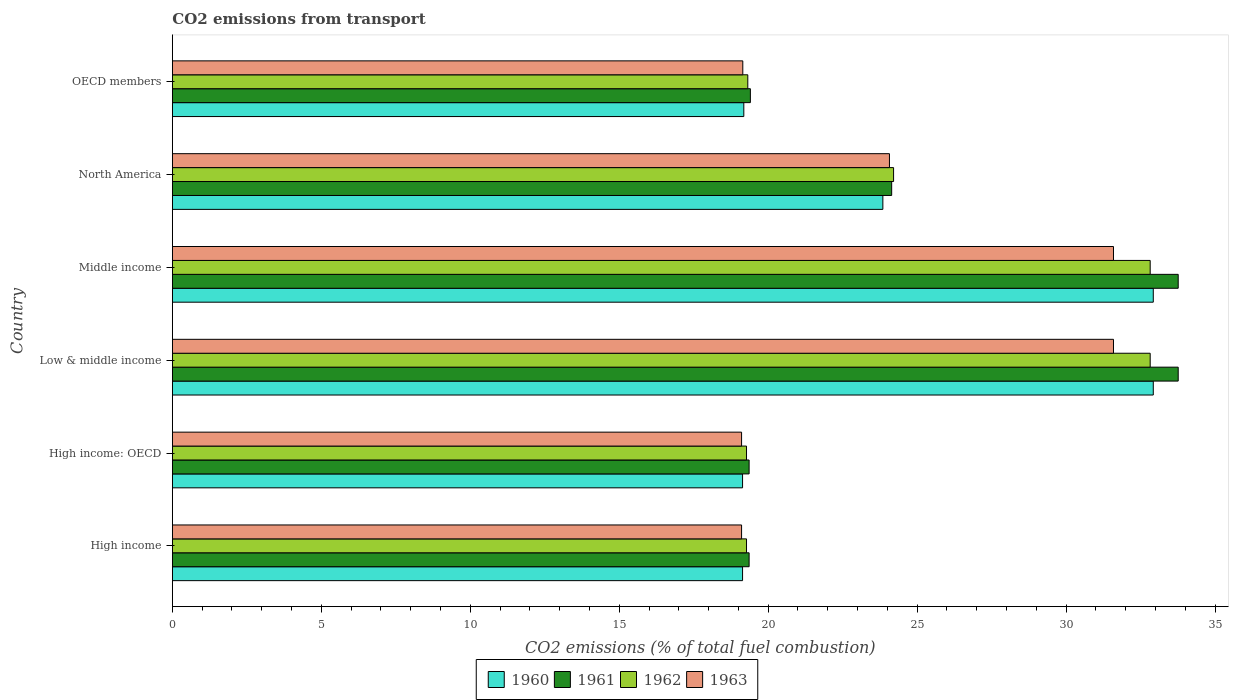Are the number of bars on each tick of the Y-axis equal?
Your answer should be very brief. Yes. In how many cases, is the number of bars for a given country not equal to the number of legend labels?
Make the answer very short. 0. What is the total CO2 emitted in 1960 in OECD members?
Your response must be concise. 19.18. Across all countries, what is the maximum total CO2 emitted in 1962?
Offer a terse response. 32.82. Across all countries, what is the minimum total CO2 emitted in 1962?
Your response must be concise. 19.27. In which country was the total CO2 emitted in 1961 maximum?
Ensure brevity in your answer.  Low & middle income. What is the total total CO2 emitted in 1962 in the graph?
Your answer should be very brief. 147.72. What is the difference between the total CO2 emitted in 1963 in High income and that in Middle income?
Offer a very short reply. -12.48. What is the difference between the total CO2 emitted in 1963 in OECD members and the total CO2 emitted in 1960 in High income?
Offer a terse response. 0.01. What is the average total CO2 emitted in 1960 per country?
Your response must be concise. 24.53. What is the difference between the total CO2 emitted in 1960 and total CO2 emitted in 1963 in High income: OECD?
Your answer should be very brief. 0.03. In how many countries, is the total CO2 emitted in 1963 greater than 7 ?
Your answer should be very brief. 6. What is the ratio of the total CO2 emitted in 1960 in Middle income to that in North America?
Offer a very short reply. 1.38. Is the total CO2 emitted in 1960 in High income: OECD less than that in Middle income?
Provide a short and direct response. Yes. Is the difference between the total CO2 emitted in 1960 in North America and OECD members greater than the difference between the total CO2 emitted in 1963 in North America and OECD members?
Keep it short and to the point. No. What is the difference between the highest and the lowest total CO2 emitted in 1960?
Your response must be concise. 13.79. In how many countries, is the total CO2 emitted in 1963 greater than the average total CO2 emitted in 1963 taken over all countries?
Offer a very short reply. 2. Is the sum of the total CO2 emitted in 1960 in High income: OECD and North America greater than the maximum total CO2 emitted in 1961 across all countries?
Provide a succinct answer. Yes. Is it the case that in every country, the sum of the total CO2 emitted in 1963 and total CO2 emitted in 1960 is greater than the sum of total CO2 emitted in 1961 and total CO2 emitted in 1962?
Your answer should be compact. No. What does the 3rd bar from the bottom in Middle income represents?
Provide a short and direct response. 1962. How many countries are there in the graph?
Provide a succinct answer. 6. What is the difference between two consecutive major ticks on the X-axis?
Your answer should be very brief. 5. Are the values on the major ticks of X-axis written in scientific E-notation?
Offer a very short reply. No. How many legend labels are there?
Your answer should be very brief. 4. How are the legend labels stacked?
Ensure brevity in your answer.  Horizontal. What is the title of the graph?
Offer a terse response. CO2 emissions from transport. Does "1981" appear as one of the legend labels in the graph?
Give a very brief answer. No. What is the label or title of the X-axis?
Make the answer very short. CO2 emissions (% of total fuel combustion). What is the CO2 emissions (% of total fuel combustion) of 1960 in High income?
Ensure brevity in your answer.  19.14. What is the CO2 emissions (% of total fuel combustion) of 1961 in High income?
Your response must be concise. 19.36. What is the CO2 emissions (% of total fuel combustion) of 1962 in High income?
Your answer should be very brief. 19.27. What is the CO2 emissions (% of total fuel combustion) of 1963 in High income?
Your answer should be very brief. 19.11. What is the CO2 emissions (% of total fuel combustion) in 1960 in High income: OECD?
Keep it short and to the point. 19.14. What is the CO2 emissions (% of total fuel combustion) in 1961 in High income: OECD?
Your response must be concise. 19.36. What is the CO2 emissions (% of total fuel combustion) in 1962 in High income: OECD?
Your answer should be very brief. 19.27. What is the CO2 emissions (% of total fuel combustion) of 1963 in High income: OECD?
Ensure brevity in your answer.  19.11. What is the CO2 emissions (% of total fuel combustion) in 1960 in Low & middle income?
Your answer should be very brief. 32.93. What is the CO2 emissions (% of total fuel combustion) of 1961 in Low & middle income?
Keep it short and to the point. 33.76. What is the CO2 emissions (% of total fuel combustion) of 1962 in Low & middle income?
Your answer should be compact. 32.82. What is the CO2 emissions (% of total fuel combustion) of 1963 in Low & middle income?
Your answer should be very brief. 31.59. What is the CO2 emissions (% of total fuel combustion) of 1960 in Middle income?
Offer a very short reply. 32.93. What is the CO2 emissions (% of total fuel combustion) of 1961 in Middle income?
Ensure brevity in your answer.  33.76. What is the CO2 emissions (% of total fuel combustion) in 1962 in Middle income?
Provide a short and direct response. 32.82. What is the CO2 emissions (% of total fuel combustion) of 1963 in Middle income?
Offer a terse response. 31.59. What is the CO2 emissions (% of total fuel combustion) of 1960 in North America?
Offer a terse response. 23.85. What is the CO2 emissions (% of total fuel combustion) of 1961 in North America?
Your answer should be very brief. 24.15. What is the CO2 emissions (% of total fuel combustion) of 1962 in North America?
Your answer should be compact. 24.21. What is the CO2 emissions (% of total fuel combustion) in 1963 in North America?
Provide a short and direct response. 24.07. What is the CO2 emissions (% of total fuel combustion) of 1960 in OECD members?
Provide a short and direct response. 19.18. What is the CO2 emissions (% of total fuel combustion) in 1961 in OECD members?
Give a very brief answer. 19.4. What is the CO2 emissions (% of total fuel combustion) in 1962 in OECD members?
Your response must be concise. 19.32. What is the CO2 emissions (% of total fuel combustion) of 1963 in OECD members?
Offer a terse response. 19.15. Across all countries, what is the maximum CO2 emissions (% of total fuel combustion) in 1960?
Provide a short and direct response. 32.93. Across all countries, what is the maximum CO2 emissions (% of total fuel combustion) in 1961?
Provide a succinct answer. 33.76. Across all countries, what is the maximum CO2 emissions (% of total fuel combustion) of 1962?
Your answer should be compact. 32.82. Across all countries, what is the maximum CO2 emissions (% of total fuel combustion) of 1963?
Your answer should be compact. 31.59. Across all countries, what is the minimum CO2 emissions (% of total fuel combustion) in 1960?
Keep it short and to the point. 19.14. Across all countries, what is the minimum CO2 emissions (% of total fuel combustion) in 1961?
Your answer should be very brief. 19.36. Across all countries, what is the minimum CO2 emissions (% of total fuel combustion) in 1962?
Your response must be concise. 19.27. Across all countries, what is the minimum CO2 emissions (% of total fuel combustion) of 1963?
Keep it short and to the point. 19.11. What is the total CO2 emissions (% of total fuel combustion) in 1960 in the graph?
Your response must be concise. 147.17. What is the total CO2 emissions (% of total fuel combustion) of 1961 in the graph?
Give a very brief answer. 149.8. What is the total CO2 emissions (% of total fuel combustion) of 1962 in the graph?
Give a very brief answer. 147.72. What is the total CO2 emissions (% of total fuel combustion) of 1963 in the graph?
Give a very brief answer. 144.62. What is the difference between the CO2 emissions (% of total fuel combustion) in 1960 in High income and that in High income: OECD?
Your answer should be very brief. 0. What is the difference between the CO2 emissions (% of total fuel combustion) in 1961 in High income and that in High income: OECD?
Offer a very short reply. 0. What is the difference between the CO2 emissions (% of total fuel combustion) of 1962 in High income and that in High income: OECD?
Your answer should be very brief. 0. What is the difference between the CO2 emissions (% of total fuel combustion) in 1963 in High income and that in High income: OECD?
Make the answer very short. 0. What is the difference between the CO2 emissions (% of total fuel combustion) of 1960 in High income and that in Low & middle income?
Offer a very short reply. -13.79. What is the difference between the CO2 emissions (% of total fuel combustion) of 1961 in High income and that in Low & middle income?
Provide a succinct answer. -14.4. What is the difference between the CO2 emissions (% of total fuel combustion) in 1962 in High income and that in Low & middle income?
Keep it short and to the point. -13.55. What is the difference between the CO2 emissions (% of total fuel combustion) of 1963 in High income and that in Low & middle income?
Offer a very short reply. -12.48. What is the difference between the CO2 emissions (% of total fuel combustion) in 1960 in High income and that in Middle income?
Provide a succinct answer. -13.79. What is the difference between the CO2 emissions (% of total fuel combustion) in 1961 in High income and that in Middle income?
Give a very brief answer. -14.4. What is the difference between the CO2 emissions (% of total fuel combustion) of 1962 in High income and that in Middle income?
Provide a succinct answer. -13.55. What is the difference between the CO2 emissions (% of total fuel combustion) of 1963 in High income and that in Middle income?
Provide a succinct answer. -12.48. What is the difference between the CO2 emissions (% of total fuel combustion) in 1960 in High income and that in North America?
Your response must be concise. -4.71. What is the difference between the CO2 emissions (% of total fuel combustion) of 1961 in High income and that in North America?
Provide a succinct answer. -4.79. What is the difference between the CO2 emissions (% of total fuel combustion) in 1962 in High income and that in North America?
Give a very brief answer. -4.94. What is the difference between the CO2 emissions (% of total fuel combustion) of 1963 in High income and that in North America?
Give a very brief answer. -4.96. What is the difference between the CO2 emissions (% of total fuel combustion) in 1960 in High income and that in OECD members?
Keep it short and to the point. -0.04. What is the difference between the CO2 emissions (% of total fuel combustion) of 1961 in High income and that in OECD members?
Give a very brief answer. -0.04. What is the difference between the CO2 emissions (% of total fuel combustion) of 1962 in High income and that in OECD members?
Ensure brevity in your answer.  -0.04. What is the difference between the CO2 emissions (% of total fuel combustion) in 1963 in High income and that in OECD members?
Provide a succinct answer. -0.04. What is the difference between the CO2 emissions (% of total fuel combustion) of 1960 in High income: OECD and that in Low & middle income?
Keep it short and to the point. -13.79. What is the difference between the CO2 emissions (% of total fuel combustion) of 1961 in High income: OECD and that in Low & middle income?
Your answer should be very brief. -14.4. What is the difference between the CO2 emissions (% of total fuel combustion) of 1962 in High income: OECD and that in Low & middle income?
Ensure brevity in your answer.  -13.55. What is the difference between the CO2 emissions (% of total fuel combustion) in 1963 in High income: OECD and that in Low & middle income?
Provide a short and direct response. -12.48. What is the difference between the CO2 emissions (% of total fuel combustion) of 1960 in High income: OECD and that in Middle income?
Give a very brief answer. -13.79. What is the difference between the CO2 emissions (% of total fuel combustion) of 1961 in High income: OECD and that in Middle income?
Offer a very short reply. -14.4. What is the difference between the CO2 emissions (% of total fuel combustion) of 1962 in High income: OECD and that in Middle income?
Ensure brevity in your answer.  -13.55. What is the difference between the CO2 emissions (% of total fuel combustion) in 1963 in High income: OECD and that in Middle income?
Your answer should be very brief. -12.48. What is the difference between the CO2 emissions (% of total fuel combustion) in 1960 in High income: OECD and that in North America?
Provide a short and direct response. -4.71. What is the difference between the CO2 emissions (% of total fuel combustion) in 1961 in High income: OECD and that in North America?
Ensure brevity in your answer.  -4.79. What is the difference between the CO2 emissions (% of total fuel combustion) in 1962 in High income: OECD and that in North America?
Your answer should be very brief. -4.94. What is the difference between the CO2 emissions (% of total fuel combustion) in 1963 in High income: OECD and that in North America?
Provide a short and direct response. -4.96. What is the difference between the CO2 emissions (% of total fuel combustion) in 1960 in High income: OECD and that in OECD members?
Provide a short and direct response. -0.04. What is the difference between the CO2 emissions (% of total fuel combustion) of 1961 in High income: OECD and that in OECD members?
Offer a very short reply. -0.04. What is the difference between the CO2 emissions (% of total fuel combustion) in 1962 in High income: OECD and that in OECD members?
Provide a short and direct response. -0.04. What is the difference between the CO2 emissions (% of total fuel combustion) in 1963 in High income: OECD and that in OECD members?
Your answer should be very brief. -0.04. What is the difference between the CO2 emissions (% of total fuel combustion) of 1960 in Low & middle income and that in Middle income?
Your response must be concise. 0. What is the difference between the CO2 emissions (% of total fuel combustion) in 1960 in Low & middle income and that in North America?
Provide a short and direct response. 9.08. What is the difference between the CO2 emissions (% of total fuel combustion) in 1961 in Low & middle income and that in North America?
Provide a succinct answer. 9.62. What is the difference between the CO2 emissions (% of total fuel combustion) in 1962 in Low & middle income and that in North America?
Your response must be concise. 8.61. What is the difference between the CO2 emissions (% of total fuel combustion) of 1963 in Low & middle income and that in North America?
Give a very brief answer. 7.52. What is the difference between the CO2 emissions (% of total fuel combustion) in 1960 in Low & middle income and that in OECD members?
Make the answer very short. 13.75. What is the difference between the CO2 emissions (% of total fuel combustion) of 1961 in Low & middle income and that in OECD members?
Make the answer very short. 14.36. What is the difference between the CO2 emissions (% of total fuel combustion) in 1962 in Low & middle income and that in OECD members?
Your answer should be very brief. 13.51. What is the difference between the CO2 emissions (% of total fuel combustion) of 1963 in Low & middle income and that in OECD members?
Keep it short and to the point. 12.44. What is the difference between the CO2 emissions (% of total fuel combustion) of 1960 in Middle income and that in North America?
Offer a terse response. 9.08. What is the difference between the CO2 emissions (% of total fuel combustion) in 1961 in Middle income and that in North America?
Provide a succinct answer. 9.62. What is the difference between the CO2 emissions (% of total fuel combustion) of 1962 in Middle income and that in North America?
Offer a terse response. 8.61. What is the difference between the CO2 emissions (% of total fuel combustion) of 1963 in Middle income and that in North America?
Your answer should be very brief. 7.52. What is the difference between the CO2 emissions (% of total fuel combustion) in 1960 in Middle income and that in OECD members?
Offer a very short reply. 13.75. What is the difference between the CO2 emissions (% of total fuel combustion) of 1961 in Middle income and that in OECD members?
Ensure brevity in your answer.  14.36. What is the difference between the CO2 emissions (% of total fuel combustion) in 1962 in Middle income and that in OECD members?
Make the answer very short. 13.51. What is the difference between the CO2 emissions (% of total fuel combustion) in 1963 in Middle income and that in OECD members?
Offer a terse response. 12.44. What is the difference between the CO2 emissions (% of total fuel combustion) in 1960 in North America and that in OECD members?
Make the answer very short. 4.67. What is the difference between the CO2 emissions (% of total fuel combustion) in 1961 in North America and that in OECD members?
Your response must be concise. 4.74. What is the difference between the CO2 emissions (% of total fuel combustion) in 1962 in North America and that in OECD members?
Provide a short and direct response. 4.89. What is the difference between the CO2 emissions (% of total fuel combustion) in 1963 in North America and that in OECD members?
Keep it short and to the point. 4.92. What is the difference between the CO2 emissions (% of total fuel combustion) in 1960 in High income and the CO2 emissions (% of total fuel combustion) in 1961 in High income: OECD?
Make the answer very short. -0.22. What is the difference between the CO2 emissions (% of total fuel combustion) of 1960 in High income and the CO2 emissions (% of total fuel combustion) of 1962 in High income: OECD?
Your answer should be very brief. -0.13. What is the difference between the CO2 emissions (% of total fuel combustion) of 1960 in High income and the CO2 emissions (% of total fuel combustion) of 1963 in High income: OECD?
Your answer should be compact. 0.03. What is the difference between the CO2 emissions (% of total fuel combustion) of 1961 in High income and the CO2 emissions (% of total fuel combustion) of 1962 in High income: OECD?
Ensure brevity in your answer.  0.09. What is the difference between the CO2 emissions (% of total fuel combustion) in 1961 in High income and the CO2 emissions (% of total fuel combustion) in 1963 in High income: OECD?
Give a very brief answer. 0.25. What is the difference between the CO2 emissions (% of total fuel combustion) of 1962 in High income and the CO2 emissions (% of total fuel combustion) of 1963 in High income: OECD?
Offer a very short reply. 0.17. What is the difference between the CO2 emissions (% of total fuel combustion) in 1960 in High income and the CO2 emissions (% of total fuel combustion) in 1961 in Low & middle income?
Your response must be concise. -14.62. What is the difference between the CO2 emissions (% of total fuel combustion) of 1960 in High income and the CO2 emissions (% of total fuel combustion) of 1962 in Low & middle income?
Your answer should be compact. -13.68. What is the difference between the CO2 emissions (% of total fuel combustion) in 1960 in High income and the CO2 emissions (% of total fuel combustion) in 1963 in Low & middle income?
Your response must be concise. -12.45. What is the difference between the CO2 emissions (% of total fuel combustion) in 1961 in High income and the CO2 emissions (% of total fuel combustion) in 1962 in Low & middle income?
Make the answer very short. -13.46. What is the difference between the CO2 emissions (% of total fuel combustion) in 1961 in High income and the CO2 emissions (% of total fuel combustion) in 1963 in Low & middle income?
Ensure brevity in your answer.  -12.23. What is the difference between the CO2 emissions (% of total fuel combustion) in 1962 in High income and the CO2 emissions (% of total fuel combustion) in 1963 in Low & middle income?
Offer a terse response. -12.32. What is the difference between the CO2 emissions (% of total fuel combustion) of 1960 in High income and the CO2 emissions (% of total fuel combustion) of 1961 in Middle income?
Your answer should be compact. -14.62. What is the difference between the CO2 emissions (% of total fuel combustion) of 1960 in High income and the CO2 emissions (% of total fuel combustion) of 1962 in Middle income?
Your response must be concise. -13.68. What is the difference between the CO2 emissions (% of total fuel combustion) of 1960 in High income and the CO2 emissions (% of total fuel combustion) of 1963 in Middle income?
Offer a terse response. -12.45. What is the difference between the CO2 emissions (% of total fuel combustion) in 1961 in High income and the CO2 emissions (% of total fuel combustion) in 1962 in Middle income?
Ensure brevity in your answer.  -13.46. What is the difference between the CO2 emissions (% of total fuel combustion) of 1961 in High income and the CO2 emissions (% of total fuel combustion) of 1963 in Middle income?
Give a very brief answer. -12.23. What is the difference between the CO2 emissions (% of total fuel combustion) in 1962 in High income and the CO2 emissions (% of total fuel combustion) in 1963 in Middle income?
Keep it short and to the point. -12.32. What is the difference between the CO2 emissions (% of total fuel combustion) of 1960 in High income and the CO2 emissions (% of total fuel combustion) of 1961 in North America?
Provide a succinct answer. -5.01. What is the difference between the CO2 emissions (% of total fuel combustion) of 1960 in High income and the CO2 emissions (% of total fuel combustion) of 1962 in North America?
Offer a terse response. -5.07. What is the difference between the CO2 emissions (% of total fuel combustion) in 1960 in High income and the CO2 emissions (% of total fuel combustion) in 1963 in North America?
Provide a short and direct response. -4.93. What is the difference between the CO2 emissions (% of total fuel combustion) in 1961 in High income and the CO2 emissions (% of total fuel combustion) in 1962 in North America?
Give a very brief answer. -4.85. What is the difference between the CO2 emissions (% of total fuel combustion) of 1961 in High income and the CO2 emissions (% of total fuel combustion) of 1963 in North America?
Give a very brief answer. -4.71. What is the difference between the CO2 emissions (% of total fuel combustion) of 1962 in High income and the CO2 emissions (% of total fuel combustion) of 1963 in North America?
Make the answer very short. -4.8. What is the difference between the CO2 emissions (% of total fuel combustion) of 1960 in High income and the CO2 emissions (% of total fuel combustion) of 1961 in OECD members?
Offer a very short reply. -0.26. What is the difference between the CO2 emissions (% of total fuel combustion) in 1960 in High income and the CO2 emissions (% of total fuel combustion) in 1962 in OECD members?
Your response must be concise. -0.18. What is the difference between the CO2 emissions (% of total fuel combustion) of 1960 in High income and the CO2 emissions (% of total fuel combustion) of 1963 in OECD members?
Give a very brief answer. -0.01. What is the difference between the CO2 emissions (% of total fuel combustion) in 1961 in High income and the CO2 emissions (% of total fuel combustion) in 1962 in OECD members?
Your response must be concise. 0.04. What is the difference between the CO2 emissions (% of total fuel combustion) in 1961 in High income and the CO2 emissions (% of total fuel combustion) in 1963 in OECD members?
Your response must be concise. 0.21. What is the difference between the CO2 emissions (% of total fuel combustion) in 1962 in High income and the CO2 emissions (% of total fuel combustion) in 1963 in OECD members?
Provide a succinct answer. 0.13. What is the difference between the CO2 emissions (% of total fuel combustion) in 1960 in High income: OECD and the CO2 emissions (% of total fuel combustion) in 1961 in Low & middle income?
Your answer should be very brief. -14.62. What is the difference between the CO2 emissions (% of total fuel combustion) in 1960 in High income: OECD and the CO2 emissions (% of total fuel combustion) in 1962 in Low & middle income?
Provide a short and direct response. -13.68. What is the difference between the CO2 emissions (% of total fuel combustion) in 1960 in High income: OECD and the CO2 emissions (% of total fuel combustion) in 1963 in Low & middle income?
Make the answer very short. -12.45. What is the difference between the CO2 emissions (% of total fuel combustion) of 1961 in High income: OECD and the CO2 emissions (% of total fuel combustion) of 1962 in Low & middle income?
Make the answer very short. -13.46. What is the difference between the CO2 emissions (% of total fuel combustion) in 1961 in High income: OECD and the CO2 emissions (% of total fuel combustion) in 1963 in Low & middle income?
Provide a succinct answer. -12.23. What is the difference between the CO2 emissions (% of total fuel combustion) in 1962 in High income: OECD and the CO2 emissions (% of total fuel combustion) in 1963 in Low & middle income?
Offer a very short reply. -12.32. What is the difference between the CO2 emissions (% of total fuel combustion) in 1960 in High income: OECD and the CO2 emissions (% of total fuel combustion) in 1961 in Middle income?
Give a very brief answer. -14.62. What is the difference between the CO2 emissions (% of total fuel combustion) of 1960 in High income: OECD and the CO2 emissions (% of total fuel combustion) of 1962 in Middle income?
Your answer should be compact. -13.68. What is the difference between the CO2 emissions (% of total fuel combustion) of 1960 in High income: OECD and the CO2 emissions (% of total fuel combustion) of 1963 in Middle income?
Offer a terse response. -12.45. What is the difference between the CO2 emissions (% of total fuel combustion) in 1961 in High income: OECD and the CO2 emissions (% of total fuel combustion) in 1962 in Middle income?
Your response must be concise. -13.46. What is the difference between the CO2 emissions (% of total fuel combustion) in 1961 in High income: OECD and the CO2 emissions (% of total fuel combustion) in 1963 in Middle income?
Give a very brief answer. -12.23. What is the difference between the CO2 emissions (% of total fuel combustion) in 1962 in High income: OECD and the CO2 emissions (% of total fuel combustion) in 1963 in Middle income?
Offer a terse response. -12.32. What is the difference between the CO2 emissions (% of total fuel combustion) of 1960 in High income: OECD and the CO2 emissions (% of total fuel combustion) of 1961 in North America?
Your answer should be very brief. -5.01. What is the difference between the CO2 emissions (% of total fuel combustion) of 1960 in High income: OECD and the CO2 emissions (% of total fuel combustion) of 1962 in North America?
Provide a succinct answer. -5.07. What is the difference between the CO2 emissions (% of total fuel combustion) in 1960 in High income: OECD and the CO2 emissions (% of total fuel combustion) in 1963 in North America?
Give a very brief answer. -4.93. What is the difference between the CO2 emissions (% of total fuel combustion) in 1961 in High income: OECD and the CO2 emissions (% of total fuel combustion) in 1962 in North America?
Offer a terse response. -4.85. What is the difference between the CO2 emissions (% of total fuel combustion) in 1961 in High income: OECD and the CO2 emissions (% of total fuel combustion) in 1963 in North America?
Your answer should be compact. -4.71. What is the difference between the CO2 emissions (% of total fuel combustion) of 1962 in High income: OECD and the CO2 emissions (% of total fuel combustion) of 1963 in North America?
Your answer should be compact. -4.8. What is the difference between the CO2 emissions (% of total fuel combustion) in 1960 in High income: OECD and the CO2 emissions (% of total fuel combustion) in 1961 in OECD members?
Give a very brief answer. -0.26. What is the difference between the CO2 emissions (% of total fuel combustion) of 1960 in High income: OECD and the CO2 emissions (% of total fuel combustion) of 1962 in OECD members?
Offer a very short reply. -0.18. What is the difference between the CO2 emissions (% of total fuel combustion) of 1960 in High income: OECD and the CO2 emissions (% of total fuel combustion) of 1963 in OECD members?
Your answer should be compact. -0.01. What is the difference between the CO2 emissions (% of total fuel combustion) in 1961 in High income: OECD and the CO2 emissions (% of total fuel combustion) in 1962 in OECD members?
Your answer should be very brief. 0.04. What is the difference between the CO2 emissions (% of total fuel combustion) in 1961 in High income: OECD and the CO2 emissions (% of total fuel combustion) in 1963 in OECD members?
Ensure brevity in your answer.  0.21. What is the difference between the CO2 emissions (% of total fuel combustion) of 1962 in High income: OECD and the CO2 emissions (% of total fuel combustion) of 1963 in OECD members?
Offer a very short reply. 0.13. What is the difference between the CO2 emissions (% of total fuel combustion) in 1960 in Low & middle income and the CO2 emissions (% of total fuel combustion) in 1961 in Middle income?
Your answer should be compact. -0.84. What is the difference between the CO2 emissions (% of total fuel combustion) of 1960 in Low & middle income and the CO2 emissions (% of total fuel combustion) of 1962 in Middle income?
Ensure brevity in your answer.  0.1. What is the difference between the CO2 emissions (% of total fuel combustion) of 1960 in Low & middle income and the CO2 emissions (% of total fuel combustion) of 1963 in Middle income?
Ensure brevity in your answer.  1.34. What is the difference between the CO2 emissions (% of total fuel combustion) in 1961 in Low & middle income and the CO2 emissions (% of total fuel combustion) in 1962 in Middle income?
Provide a succinct answer. 0.94. What is the difference between the CO2 emissions (% of total fuel combustion) in 1961 in Low & middle income and the CO2 emissions (% of total fuel combustion) in 1963 in Middle income?
Make the answer very short. 2.17. What is the difference between the CO2 emissions (% of total fuel combustion) of 1962 in Low & middle income and the CO2 emissions (% of total fuel combustion) of 1963 in Middle income?
Your answer should be very brief. 1.23. What is the difference between the CO2 emissions (% of total fuel combustion) in 1960 in Low & middle income and the CO2 emissions (% of total fuel combustion) in 1961 in North America?
Keep it short and to the point. 8.78. What is the difference between the CO2 emissions (% of total fuel combustion) of 1960 in Low & middle income and the CO2 emissions (% of total fuel combustion) of 1962 in North America?
Provide a succinct answer. 8.72. What is the difference between the CO2 emissions (% of total fuel combustion) of 1960 in Low & middle income and the CO2 emissions (% of total fuel combustion) of 1963 in North America?
Give a very brief answer. 8.86. What is the difference between the CO2 emissions (% of total fuel combustion) in 1961 in Low & middle income and the CO2 emissions (% of total fuel combustion) in 1962 in North America?
Provide a succinct answer. 9.55. What is the difference between the CO2 emissions (% of total fuel combustion) in 1961 in Low & middle income and the CO2 emissions (% of total fuel combustion) in 1963 in North America?
Your answer should be very brief. 9.69. What is the difference between the CO2 emissions (% of total fuel combustion) of 1962 in Low & middle income and the CO2 emissions (% of total fuel combustion) of 1963 in North America?
Give a very brief answer. 8.75. What is the difference between the CO2 emissions (% of total fuel combustion) in 1960 in Low & middle income and the CO2 emissions (% of total fuel combustion) in 1961 in OECD members?
Ensure brevity in your answer.  13.53. What is the difference between the CO2 emissions (% of total fuel combustion) of 1960 in Low & middle income and the CO2 emissions (% of total fuel combustion) of 1962 in OECD members?
Ensure brevity in your answer.  13.61. What is the difference between the CO2 emissions (% of total fuel combustion) of 1960 in Low & middle income and the CO2 emissions (% of total fuel combustion) of 1963 in OECD members?
Offer a very short reply. 13.78. What is the difference between the CO2 emissions (% of total fuel combustion) in 1961 in Low & middle income and the CO2 emissions (% of total fuel combustion) in 1962 in OECD members?
Provide a short and direct response. 14.45. What is the difference between the CO2 emissions (% of total fuel combustion) of 1961 in Low & middle income and the CO2 emissions (% of total fuel combustion) of 1963 in OECD members?
Offer a terse response. 14.62. What is the difference between the CO2 emissions (% of total fuel combustion) of 1962 in Low & middle income and the CO2 emissions (% of total fuel combustion) of 1963 in OECD members?
Offer a very short reply. 13.68. What is the difference between the CO2 emissions (% of total fuel combustion) in 1960 in Middle income and the CO2 emissions (% of total fuel combustion) in 1961 in North America?
Provide a succinct answer. 8.78. What is the difference between the CO2 emissions (% of total fuel combustion) of 1960 in Middle income and the CO2 emissions (% of total fuel combustion) of 1962 in North America?
Your response must be concise. 8.72. What is the difference between the CO2 emissions (% of total fuel combustion) in 1960 in Middle income and the CO2 emissions (% of total fuel combustion) in 1963 in North America?
Keep it short and to the point. 8.86. What is the difference between the CO2 emissions (% of total fuel combustion) of 1961 in Middle income and the CO2 emissions (% of total fuel combustion) of 1962 in North America?
Your answer should be compact. 9.55. What is the difference between the CO2 emissions (% of total fuel combustion) in 1961 in Middle income and the CO2 emissions (% of total fuel combustion) in 1963 in North America?
Give a very brief answer. 9.69. What is the difference between the CO2 emissions (% of total fuel combustion) in 1962 in Middle income and the CO2 emissions (% of total fuel combustion) in 1963 in North America?
Your answer should be very brief. 8.75. What is the difference between the CO2 emissions (% of total fuel combustion) of 1960 in Middle income and the CO2 emissions (% of total fuel combustion) of 1961 in OECD members?
Offer a terse response. 13.53. What is the difference between the CO2 emissions (% of total fuel combustion) in 1960 in Middle income and the CO2 emissions (% of total fuel combustion) in 1962 in OECD members?
Offer a terse response. 13.61. What is the difference between the CO2 emissions (% of total fuel combustion) of 1960 in Middle income and the CO2 emissions (% of total fuel combustion) of 1963 in OECD members?
Ensure brevity in your answer.  13.78. What is the difference between the CO2 emissions (% of total fuel combustion) of 1961 in Middle income and the CO2 emissions (% of total fuel combustion) of 1962 in OECD members?
Keep it short and to the point. 14.45. What is the difference between the CO2 emissions (% of total fuel combustion) of 1961 in Middle income and the CO2 emissions (% of total fuel combustion) of 1963 in OECD members?
Your response must be concise. 14.62. What is the difference between the CO2 emissions (% of total fuel combustion) of 1962 in Middle income and the CO2 emissions (% of total fuel combustion) of 1963 in OECD members?
Keep it short and to the point. 13.68. What is the difference between the CO2 emissions (% of total fuel combustion) of 1960 in North America and the CO2 emissions (% of total fuel combustion) of 1961 in OECD members?
Provide a short and direct response. 4.45. What is the difference between the CO2 emissions (% of total fuel combustion) in 1960 in North America and the CO2 emissions (% of total fuel combustion) in 1962 in OECD members?
Your answer should be compact. 4.53. What is the difference between the CO2 emissions (% of total fuel combustion) of 1960 in North America and the CO2 emissions (% of total fuel combustion) of 1963 in OECD members?
Give a very brief answer. 4.7. What is the difference between the CO2 emissions (% of total fuel combustion) in 1961 in North America and the CO2 emissions (% of total fuel combustion) in 1962 in OECD members?
Make the answer very short. 4.83. What is the difference between the CO2 emissions (% of total fuel combustion) in 1961 in North America and the CO2 emissions (% of total fuel combustion) in 1963 in OECD members?
Provide a short and direct response. 5. What is the difference between the CO2 emissions (% of total fuel combustion) of 1962 in North America and the CO2 emissions (% of total fuel combustion) of 1963 in OECD members?
Your answer should be very brief. 5.06. What is the average CO2 emissions (% of total fuel combustion) in 1960 per country?
Keep it short and to the point. 24.53. What is the average CO2 emissions (% of total fuel combustion) in 1961 per country?
Provide a succinct answer. 24.97. What is the average CO2 emissions (% of total fuel combustion) in 1962 per country?
Offer a terse response. 24.62. What is the average CO2 emissions (% of total fuel combustion) in 1963 per country?
Give a very brief answer. 24.1. What is the difference between the CO2 emissions (% of total fuel combustion) of 1960 and CO2 emissions (% of total fuel combustion) of 1961 in High income?
Provide a short and direct response. -0.22. What is the difference between the CO2 emissions (% of total fuel combustion) of 1960 and CO2 emissions (% of total fuel combustion) of 1962 in High income?
Your answer should be very brief. -0.13. What is the difference between the CO2 emissions (% of total fuel combustion) in 1960 and CO2 emissions (% of total fuel combustion) in 1963 in High income?
Offer a very short reply. 0.03. What is the difference between the CO2 emissions (% of total fuel combustion) in 1961 and CO2 emissions (% of total fuel combustion) in 1962 in High income?
Offer a very short reply. 0.09. What is the difference between the CO2 emissions (% of total fuel combustion) of 1961 and CO2 emissions (% of total fuel combustion) of 1963 in High income?
Offer a very short reply. 0.25. What is the difference between the CO2 emissions (% of total fuel combustion) of 1962 and CO2 emissions (% of total fuel combustion) of 1963 in High income?
Provide a succinct answer. 0.17. What is the difference between the CO2 emissions (% of total fuel combustion) of 1960 and CO2 emissions (% of total fuel combustion) of 1961 in High income: OECD?
Keep it short and to the point. -0.22. What is the difference between the CO2 emissions (% of total fuel combustion) in 1960 and CO2 emissions (% of total fuel combustion) in 1962 in High income: OECD?
Your response must be concise. -0.13. What is the difference between the CO2 emissions (% of total fuel combustion) in 1960 and CO2 emissions (% of total fuel combustion) in 1963 in High income: OECD?
Provide a short and direct response. 0.03. What is the difference between the CO2 emissions (% of total fuel combustion) of 1961 and CO2 emissions (% of total fuel combustion) of 1962 in High income: OECD?
Offer a terse response. 0.09. What is the difference between the CO2 emissions (% of total fuel combustion) of 1961 and CO2 emissions (% of total fuel combustion) of 1963 in High income: OECD?
Give a very brief answer. 0.25. What is the difference between the CO2 emissions (% of total fuel combustion) in 1962 and CO2 emissions (% of total fuel combustion) in 1963 in High income: OECD?
Ensure brevity in your answer.  0.17. What is the difference between the CO2 emissions (% of total fuel combustion) in 1960 and CO2 emissions (% of total fuel combustion) in 1961 in Low & middle income?
Offer a terse response. -0.84. What is the difference between the CO2 emissions (% of total fuel combustion) of 1960 and CO2 emissions (% of total fuel combustion) of 1962 in Low & middle income?
Keep it short and to the point. 0.1. What is the difference between the CO2 emissions (% of total fuel combustion) in 1960 and CO2 emissions (% of total fuel combustion) in 1963 in Low & middle income?
Your response must be concise. 1.34. What is the difference between the CO2 emissions (% of total fuel combustion) of 1961 and CO2 emissions (% of total fuel combustion) of 1962 in Low & middle income?
Give a very brief answer. 0.94. What is the difference between the CO2 emissions (% of total fuel combustion) in 1961 and CO2 emissions (% of total fuel combustion) in 1963 in Low & middle income?
Your response must be concise. 2.17. What is the difference between the CO2 emissions (% of total fuel combustion) of 1962 and CO2 emissions (% of total fuel combustion) of 1963 in Low & middle income?
Your response must be concise. 1.23. What is the difference between the CO2 emissions (% of total fuel combustion) in 1960 and CO2 emissions (% of total fuel combustion) in 1961 in Middle income?
Ensure brevity in your answer.  -0.84. What is the difference between the CO2 emissions (% of total fuel combustion) in 1960 and CO2 emissions (% of total fuel combustion) in 1962 in Middle income?
Your answer should be very brief. 0.1. What is the difference between the CO2 emissions (% of total fuel combustion) in 1960 and CO2 emissions (% of total fuel combustion) in 1963 in Middle income?
Your answer should be very brief. 1.34. What is the difference between the CO2 emissions (% of total fuel combustion) of 1961 and CO2 emissions (% of total fuel combustion) of 1962 in Middle income?
Your response must be concise. 0.94. What is the difference between the CO2 emissions (% of total fuel combustion) of 1961 and CO2 emissions (% of total fuel combustion) of 1963 in Middle income?
Your answer should be very brief. 2.17. What is the difference between the CO2 emissions (% of total fuel combustion) of 1962 and CO2 emissions (% of total fuel combustion) of 1963 in Middle income?
Make the answer very short. 1.23. What is the difference between the CO2 emissions (% of total fuel combustion) in 1960 and CO2 emissions (% of total fuel combustion) in 1961 in North America?
Give a very brief answer. -0.3. What is the difference between the CO2 emissions (% of total fuel combustion) in 1960 and CO2 emissions (% of total fuel combustion) in 1962 in North America?
Your answer should be very brief. -0.36. What is the difference between the CO2 emissions (% of total fuel combustion) in 1960 and CO2 emissions (% of total fuel combustion) in 1963 in North America?
Your answer should be very brief. -0.22. What is the difference between the CO2 emissions (% of total fuel combustion) in 1961 and CO2 emissions (% of total fuel combustion) in 1962 in North America?
Offer a very short reply. -0.06. What is the difference between the CO2 emissions (% of total fuel combustion) in 1961 and CO2 emissions (% of total fuel combustion) in 1963 in North America?
Your answer should be compact. 0.07. What is the difference between the CO2 emissions (% of total fuel combustion) in 1962 and CO2 emissions (% of total fuel combustion) in 1963 in North America?
Offer a terse response. 0.14. What is the difference between the CO2 emissions (% of total fuel combustion) in 1960 and CO2 emissions (% of total fuel combustion) in 1961 in OECD members?
Your answer should be very brief. -0.22. What is the difference between the CO2 emissions (% of total fuel combustion) of 1960 and CO2 emissions (% of total fuel combustion) of 1962 in OECD members?
Provide a short and direct response. -0.13. What is the difference between the CO2 emissions (% of total fuel combustion) in 1960 and CO2 emissions (% of total fuel combustion) in 1963 in OECD members?
Your response must be concise. 0.03. What is the difference between the CO2 emissions (% of total fuel combustion) of 1961 and CO2 emissions (% of total fuel combustion) of 1962 in OECD members?
Your answer should be compact. 0.09. What is the difference between the CO2 emissions (% of total fuel combustion) of 1961 and CO2 emissions (% of total fuel combustion) of 1963 in OECD members?
Provide a short and direct response. 0.25. What is the difference between the CO2 emissions (% of total fuel combustion) of 1962 and CO2 emissions (% of total fuel combustion) of 1963 in OECD members?
Provide a short and direct response. 0.17. What is the ratio of the CO2 emissions (% of total fuel combustion) in 1961 in High income to that in High income: OECD?
Provide a short and direct response. 1. What is the ratio of the CO2 emissions (% of total fuel combustion) of 1962 in High income to that in High income: OECD?
Keep it short and to the point. 1. What is the ratio of the CO2 emissions (% of total fuel combustion) in 1963 in High income to that in High income: OECD?
Provide a short and direct response. 1. What is the ratio of the CO2 emissions (% of total fuel combustion) in 1960 in High income to that in Low & middle income?
Keep it short and to the point. 0.58. What is the ratio of the CO2 emissions (% of total fuel combustion) of 1961 in High income to that in Low & middle income?
Offer a very short reply. 0.57. What is the ratio of the CO2 emissions (% of total fuel combustion) of 1962 in High income to that in Low & middle income?
Provide a short and direct response. 0.59. What is the ratio of the CO2 emissions (% of total fuel combustion) in 1963 in High income to that in Low & middle income?
Offer a terse response. 0.6. What is the ratio of the CO2 emissions (% of total fuel combustion) in 1960 in High income to that in Middle income?
Ensure brevity in your answer.  0.58. What is the ratio of the CO2 emissions (% of total fuel combustion) of 1961 in High income to that in Middle income?
Your answer should be very brief. 0.57. What is the ratio of the CO2 emissions (% of total fuel combustion) of 1962 in High income to that in Middle income?
Make the answer very short. 0.59. What is the ratio of the CO2 emissions (% of total fuel combustion) in 1963 in High income to that in Middle income?
Your response must be concise. 0.6. What is the ratio of the CO2 emissions (% of total fuel combustion) in 1960 in High income to that in North America?
Your answer should be compact. 0.8. What is the ratio of the CO2 emissions (% of total fuel combustion) in 1961 in High income to that in North America?
Offer a very short reply. 0.8. What is the ratio of the CO2 emissions (% of total fuel combustion) in 1962 in High income to that in North America?
Your answer should be very brief. 0.8. What is the ratio of the CO2 emissions (% of total fuel combustion) of 1963 in High income to that in North America?
Offer a terse response. 0.79. What is the ratio of the CO2 emissions (% of total fuel combustion) in 1960 in High income to that in OECD members?
Keep it short and to the point. 1. What is the ratio of the CO2 emissions (% of total fuel combustion) of 1961 in High income to that in OECD members?
Ensure brevity in your answer.  1. What is the ratio of the CO2 emissions (% of total fuel combustion) of 1960 in High income: OECD to that in Low & middle income?
Keep it short and to the point. 0.58. What is the ratio of the CO2 emissions (% of total fuel combustion) of 1961 in High income: OECD to that in Low & middle income?
Your answer should be compact. 0.57. What is the ratio of the CO2 emissions (% of total fuel combustion) in 1962 in High income: OECD to that in Low & middle income?
Offer a terse response. 0.59. What is the ratio of the CO2 emissions (% of total fuel combustion) in 1963 in High income: OECD to that in Low & middle income?
Provide a succinct answer. 0.6. What is the ratio of the CO2 emissions (% of total fuel combustion) of 1960 in High income: OECD to that in Middle income?
Your response must be concise. 0.58. What is the ratio of the CO2 emissions (% of total fuel combustion) in 1961 in High income: OECD to that in Middle income?
Your response must be concise. 0.57. What is the ratio of the CO2 emissions (% of total fuel combustion) of 1962 in High income: OECD to that in Middle income?
Your response must be concise. 0.59. What is the ratio of the CO2 emissions (% of total fuel combustion) in 1963 in High income: OECD to that in Middle income?
Offer a terse response. 0.6. What is the ratio of the CO2 emissions (% of total fuel combustion) of 1960 in High income: OECD to that in North America?
Your answer should be compact. 0.8. What is the ratio of the CO2 emissions (% of total fuel combustion) of 1961 in High income: OECD to that in North America?
Ensure brevity in your answer.  0.8. What is the ratio of the CO2 emissions (% of total fuel combustion) in 1962 in High income: OECD to that in North America?
Your answer should be very brief. 0.8. What is the ratio of the CO2 emissions (% of total fuel combustion) in 1963 in High income: OECD to that in North America?
Your answer should be compact. 0.79. What is the ratio of the CO2 emissions (% of total fuel combustion) of 1960 in Low & middle income to that in Middle income?
Give a very brief answer. 1. What is the ratio of the CO2 emissions (% of total fuel combustion) of 1962 in Low & middle income to that in Middle income?
Your answer should be compact. 1. What is the ratio of the CO2 emissions (% of total fuel combustion) of 1960 in Low & middle income to that in North America?
Your answer should be compact. 1.38. What is the ratio of the CO2 emissions (% of total fuel combustion) in 1961 in Low & middle income to that in North America?
Make the answer very short. 1.4. What is the ratio of the CO2 emissions (% of total fuel combustion) of 1962 in Low & middle income to that in North America?
Offer a very short reply. 1.36. What is the ratio of the CO2 emissions (% of total fuel combustion) in 1963 in Low & middle income to that in North America?
Ensure brevity in your answer.  1.31. What is the ratio of the CO2 emissions (% of total fuel combustion) in 1960 in Low & middle income to that in OECD members?
Make the answer very short. 1.72. What is the ratio of the CO2 emissions (% of total fuel combustion) of 1961 in Low & middle income to that in OECD members?
Your answer should be very brief. 1.74. What is the ratio of the CO2 emissions (% of total fuel combustion) of 1962 in Low & middle income to that in OECD members?
Provide a succinct answer. 1.7. What is the ratio of the CO2 emissions (% of total fuel combustion) in 1963 in Low & middle income to that in OECD members?
Keep it short and to the point. 1.65. What is the ratio of the CO2 emissions (% of total fuel combustion) of 1960 in Middle income to that in North America?
Provide a short and direct response. 1.38. What is the ratio of the CO2 emissions (% of total fuel combustion) in 1961 in Middle income to that in North America?
Your answer should be compact. 1.4. What is the ratio of the CO2 emissions (% of total fuel combustion) in 1962 in Middle income to that in North America?
Your answer should be compact. 1.36. What is the ratio of the CO2 emissions (% of total fuel combustion) in 1963 in Middle income to that in North America?
Make the answer very short. 1.31. What is the ratio of the CO2 emissions (% of total fuel combustion) in 1960 in Middle income to that in OECD members?
Provide a short and direct response. 1.72. What is the ratio of the CO2 emissions (% of total fuel combustion) of 1961 in Middle income to that in OECD members?
Provide a succinct answer. 1.74. What is the ratio of the CO2 emissions (% of total fuel combustion) of 1962 in Middle income to that in OECD members?
Offer a very short reply. 1.7. What is the ratio of the CO2 emissions (% of total fuel combustion) of 1963 in Middle income to that in OECD members?
Offer a terse response. 1.65. What is the ratio of the CO2 emissions (% of total fuel combustion) in 1960 in North America to that in OECD members?
Keep it short and to the point. 1.24. What is the ratio of the CO2 emissions (% of total fuel combustion) of 1961 in North America to that in OECD members?
Provide a short and direct response. 1.24. What is the ratio of the CO2 emissions (% of total fuel combustion) of 1962 in North America to that in OECD members?
Ensure brevity in your answer.  1.25. What is the ratio of the CO2 emissions (% of total fuel combustion) in 1963 in North America to that in OECD members?
Make the answer very short. 1.26. What is the difference between the highest and the second highest CO2 emissions (% of total fuel combustion) of 1960?
Keep it short and to the point. 0. What is the difference between the highest and the second highest CO2 emissions (% of total fuel combustion) in 1963?
Ensure brevity in your answer.  0. What is the difference between the highest and the lowest CO2 emissions (% of total fuel combustion) of 1960?
Offer a terse response. 13.79. What is the difference between the highest and the lowest CO2 emissions (% of total fuel combustion) of 1961?
Make the answer very short. 14.4. What is the difference between the highest and the lowest CO2 emissions (% of total fuel combustion) of 1962?
Keep it short and to the point. 13.55. What is the difference between the highest and the lowest CO2 emissions (% of total fuel combustion) of 1963?
Offer a terse response. 12.48. 